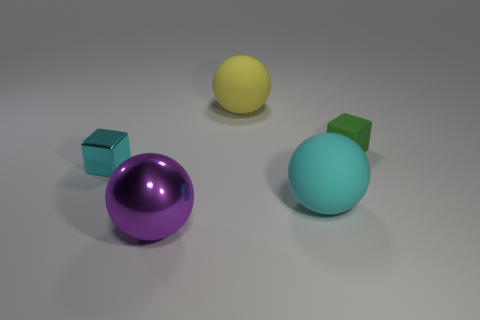Add 3 small matte cubes. How many objects exist? 8 Subtract all blocks. How many objects are left? 3 Subtract all large cyan objects. Subtract all tiny red matte objects. How many objects are left? 4 Add 1 small cubes. How many small cubes are left? 3 Add 4 tiny shiny things. How many tiny shiny things exist? 5 Subtract 0 brown spheres. How many objects are left? 5 